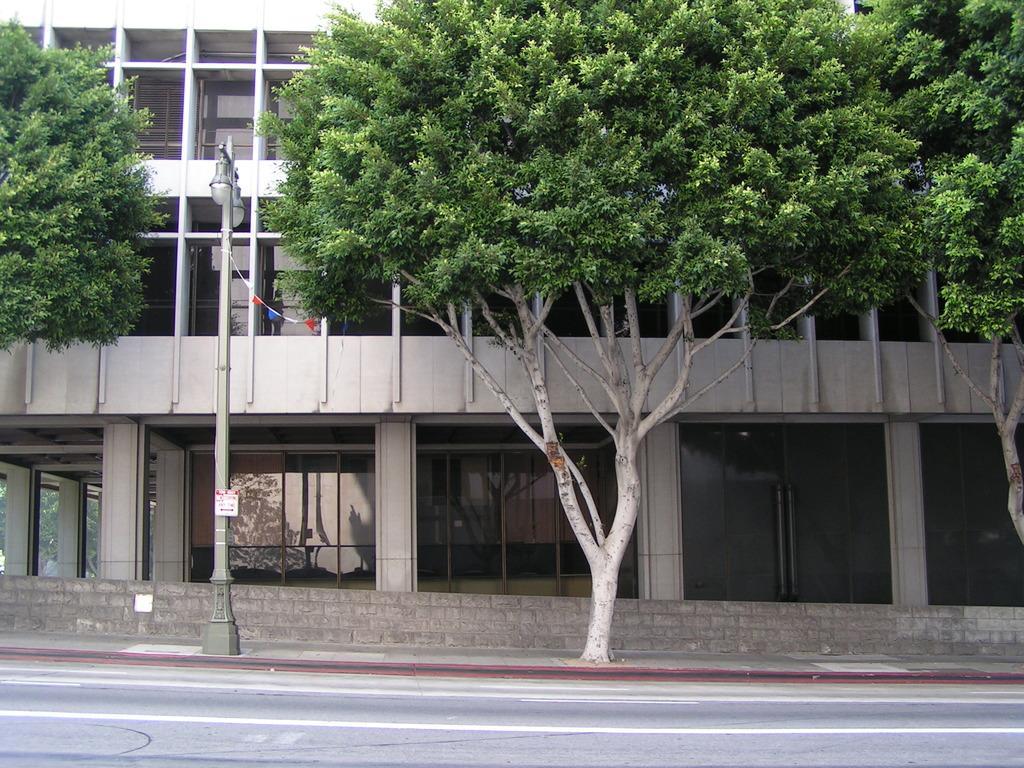Please provide a concise description of this image. In the center of the image we can see a building, door, windows, glass, wall, electric light pole, trees, board are present. At the bottom of the image road is there. 